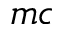Convert formula to latex. <formula><loc_0><loc_0><loc_500><loc_500>m c</formula> 